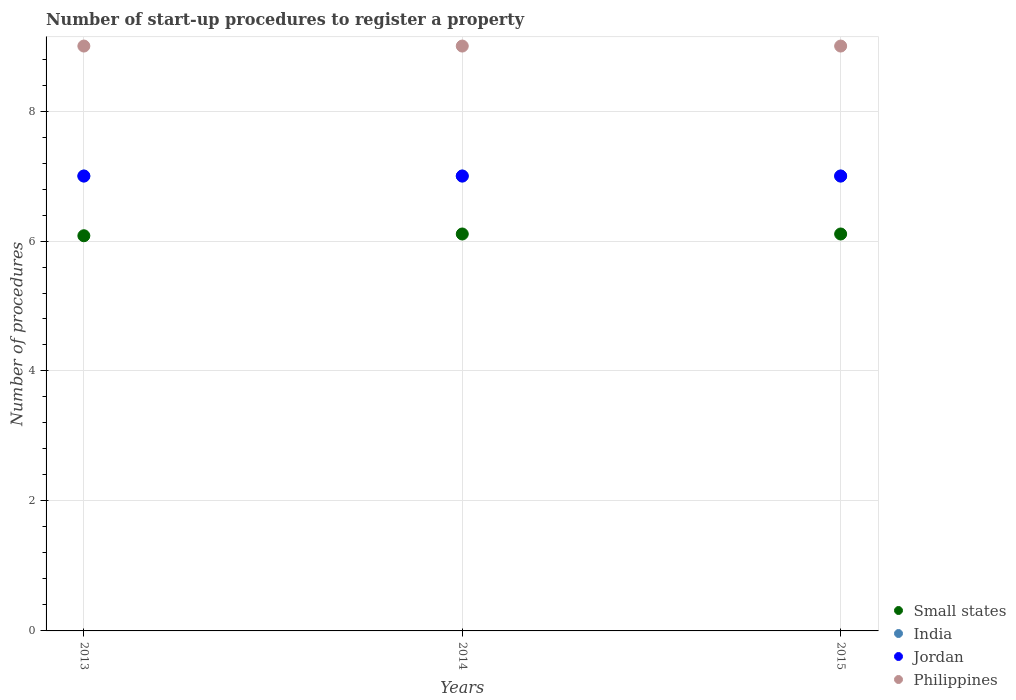How many different coloured dotlines are there?
Your response must be concise. 4. What is the number of procedures required to register a property in Philippines in 2015?
Offer a very short reply. 9. Across all years, what is the maximum number of procedures required to register a property in Jordan?
Give a very brief answer. 7. What is the total number of procedures required to register a property in Jordan in the graph?
Give a very brief answer. 21. What is the difference between the number of procedures required to register a property in Philippines in 2015 and the number of procedures required to register a property in India in 2014?
Your answer should be compact. 2. What is the average number of procedures required to register a property in Philippines per year?
Your response must be concise. 9. In the year 2014, what is the difference between the number of procedures required to register a property in India and number of procedures required to register a property in Small states?
Your response must be concise. 0.89. What is the ratio of the number of procedures required to register a property in Small states in 2013 to that in 2015?
Your answer should be very brief. 1. Is the difference between the number of procedures required to register a property in India in 2013 and 2014 greater than the difference between the number of procedures required to register a property in Small states in 2013 and 2014?
Your answer should be compact. Yes. What is the difference between the highest and the second highest number of procedures required to register a property in Philippines?
Ensure brevity in your answer.  0. In how many years, is the number of procedures required to register a property in Philippines greater than the average number of procedures required to register a property in Philippines taken over all years?
Give a very brief answer. 0. Is it the case that in every year, the sum of the number of procedures required to register a property in Small states and number of procedures required to register a property in Philippines  is greater than the sum of number of procedures required to register a property in India and number of procedures required to register a property in Jordan?
Your response must be concise. Yes. Is it the case that in every year, the sum of the number of procedures required to register a property in Philippines and number of procedures required to register a property in Jordan  is greater than the number of procedures required to register a property in Small states?
Provide a succinct answer. Yes. Does the number of procedures required to register a property in India monotonically increase over the years?
Make the answer very short. No. Is the number of procedures required to register a property in India strictly less than the number of procedures required to register a property in Small states over the years?
Your answer should be very brief. No. How many dotlines are there?
Ensure brevity in your answer.  4. What is the difference between two consecutive major ticks on the Y-axis?
Offer a terse response. 2. Does the graph contain grids?
Provide a succinct answer. Yes. How many legend labels are there?
Offer a terse response. 4. How are the legend labels stacked?
Your response must be concise. Vertical. What is the title of the graph?
Offer a terse response. Number of start-up procedures to register a property. Does "West Bank and Gaza" appear as one of the legend labels in the graph?
Provide a short and direct response. No. What is the label or title of the Y-axis?
Your response must be concise. Number of procedures. What is the Number of procedures of Small states in 2013?
Ensure brevity in your answer.  6.08. What is the Number of procedures of Small states in 2014?
Give a very brief answer. 6.11. What is the Number of procedures in Jordan in 2014?
Your answer should be compact. 7. What is the Number of procedures in Philippines in 2014?
Give a very brief answer. 9. What is the Number of procedures in Small states in 2015?
Ensure brevity in your answer.  6.11. What is the Number of procedures in India in 2015?
Your answer should be compact. 7. What is the Number of procedures of Jordan in 2015?
Your answer should be very brief. 7. What is the Number of procedures in Philippines in 2015?
Provide a succinct answer. 9. Across all years, what is the maximum Number of procedures in Small states?
Offer a terse response. 6.11. Across all years, what is the maximum Number of procedures of Jordan?
Ensure brevity in your answer.  7. Across all years, what is the minimum Number of procedures in Small states?
Your answer should be compact. 6.08. Across all years, what is the minimum Number of procedures in Jordan?
Ensure brevity in your answer.  7. What is the total Number of procedures in Small states in the graph?
Provide a succinct answer. 18.3. What is the total Number of procedures in India in the graph?
Your answer should be very brief. 21. What is the difference between the Number of procedures of Small states in 2013 and that in 2014?
Offer a very short reply. -0.03. What is the difference between the Number of procedures of India in 2013 and that in 2014?
Provide a succinct answer. 0. What is the difference between the Number of procedures in Small states in 2013 and that in 2015?
Your answer should be very brief. -0.03. What is the difference between the Number of procedures in Jordan in 2013 and that in 2015?
Provide a succinct answer. 0. What is the difference between the Number of procedures in Jordan in 2014 and that in 2015?
Keep it short and to the point. 0. What is the difference between the Number of procedures of Philippines in 2014 and that in 2015?
Your answer should be compact. 0. What is the difference between the Number of procedures in Small states in 2013 and the Number of procedures in India in 2014?
Keep it short and to the point. -0.92. What is the difference between the Number of procedures in Small states in 2013 and the Number of procedures in Jordan in 2014?
Your answer should be compact. -0.92. What is the difference between the Number of procedures in Small states in 2013 and the Number of procedures in Philippines in 2014?
Give a very brief answer. -2.92. What is the difference between the Number of procedures in India in 2013 and the Number of procedures in Philippines in 2014?
Your response must be concise. -2. What is the difference between the Number of procedures of Jordan in 2013 and the Number of procedures of Philippines in 2014?
Keep it short and to the point. -2. What is the difference between the Number of procedures in Small states in 2013 and the Number of procedures in India in 2015?
Your response must be concise. -0.92. What is the difference between the Number of procedures of Small states in 2013 and the Number of procedures of Jordan in 2015?
Offer a very short reply. -0.92. What is the difference between the Number of procedures of Small states in 2013 and the Number of procedures of Philippines in 2015?
Keep it short and to the point. -2.92. What is the difference between the Number of procedures of India in 2013 and the Number of procedures of Philippines in 2015?
Your answer should be very brief. -2. What is the difference between the Number of procedures of Small states in 2014 and the Number of procedures of India in 2015?
Make the answer very short. -0.89. What is the difference between the Number of procedures of Small states in 2014 and the Number of procedures of Jordan in 2015?
Ensure brevity in your answer.  -0.89. What is the difference between the Number of procedures in Small states in 2014 and the Number of procedures in Philippines in 2015?
Keep it short and to the point. -2.89. What is the difference between the Number of procedures in India in 2014 and the Number of procedures in Jordan in 2015?
Your answer should be compact. 0. What is the difference between the Number of procedures of India in 2014 and the Number of procedures of Philippines in 2015?
Make the answer very short. -2. What is the difference between the Number of procedures of Jordan in 2014 and the Number of procedures of Philippines in 2015?
Provide a short and direct response. -2. What is the average Number of procedures of Small states per year?
Your response must be concise. 6.1. What is the average Number of procedures of India per year?
Your answer should be very brief. 7. In the year 2013, what is the difference between the Number of procedures in Small states and Number of procedures in India?
Your answer should be very brief. -0.92. In the year 2013, what is the difference between the Number of procedures of Small states and Number of procedures of Jordan?
Your answer should be very brief. -0.92. In the year 2013, what is the difference between the Number of procedures in Small states and Number of procedures in Philippines?
Offer a terse response. -2.92. In the year 2013, what is the difference between the Number of procedures of Jordan and Number of procedures of Philippines?
Make the answer very short. -2. In the year 2014, what is the difference between the Number of procedures of Small states and Number of procedures of India?
Your answer should be compact. -0.89. In the year 2014, what is the difference between the Number of procedures in Small states and Number of procedures in Jordan?
Your answer should be very brief. -0.89. In the year 2014, what is the difference between the Number of procedures of Small states and Number of procedures of Philippines?
Offer a very short reply. -2.89. In the year 2014, what is the difference between the Number of procedures of India and Number of procedures of Jordan?
Your response must be concise. 0. In the year 2014, what is the difference between the Number of procedures of India and Number of procedures of Philippines?
Keep it short and to the point. -2. In the year 2015, what is the difference between the Number of procedures in Small states and Number of procedures in India?
Keep it short and to the point. -0.89. In the year 2015, what is the difference between the Number of procedures of Small states and Number of procedures of Jordan?
Provide a succinct answer. -0.89. In the year 2015, what is the difference between the Number of procedures of Small states and Number of procedures of Philippines?
Offer a terse response. -2.89. In the year 2015, what is the difference between the Number of procedures in India and Number of procedures in Philippines?
Keep it short and to the point. -2. In the year 2015, what is the difference between the Number of procedures in Jordan and Number of procedures in Philippines?
Provide a short and direct response. -2. What is the ratio of the Number of procedures in Philippines in 2013 to that in 2014?
Offer a very short reply. 1. What is the ratio of the Number of procedures in India in 2013 to that in 2015?
Give a very brief answer. 1. What is the ratio of the Number of procedures in Jordan in 2013 to that in 2015?
Ensure brevity in your answer.  1. What is the ratio of the Number of procedures of Jordan in 2014 to that in 2015?
Offer a very short reply. 1. What is the difference between the highest and the second highest Number of procedures of Small states?
Keep it short and to the point. 0. What is the difference between the highest and the second highest Number of procedures in Philippines?
Ensure brevity in your answer.  0. What is the difference between the highest and the lowest Number of procedures in Small states?
Ensure brevity in your answer.  0.03. What is the difference between the highest and the lowest Number of procedures in Jordan?
Ensure brevity in your answer.  0. What is the difference between the highest and the lowest Number of procedures in Philippines?
Keep it short and to the point. 0. 